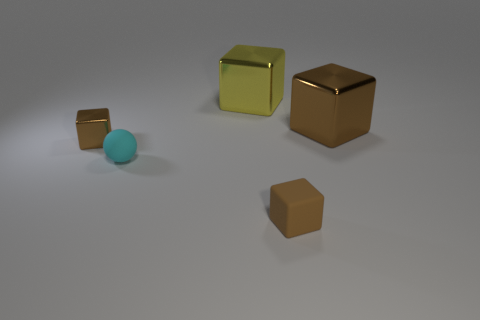Are the block in front of the small cyan ball and the object that is on the left side of the cyan thing made of the same material?
Ensure brevity in your answer.  No. How many things are either balls or large blocks on the left side of the brown rubber block?
Make the answer very short. 2. Are there any small brown rubber things that have the same shape as the big brown thing?
Your response must be concise. Yes. What is the size of the brown shiny object that is right of the tiny thing on the right side of the yellow shiny object that is to the right of the cyan rubber thing?
Keep it short and to the point. Large. Are there an equal number of large brown shiny objects that are in front of the tiny brown metal cube and large cubes that are on the left side of the tiny cyan matte object?
Make the answer very short. Yes. What is the size of the brown block that is the same material as the cyan ball?
Keep it short and to the point. Small. What is the color of the tiny metal object?
Your response must be concise. Brown. What number of objects have the same color as the small metal cube?
Keep it short and to the point. 2. What material is the brown thing that is the same size as the brown matte block?
Offer a very short reply. Metal. There is a metal thing that is behind the large brown shiny block; is there a tiny matte thing that is on the left side of it?
Your answer should be very brief. Yes. 